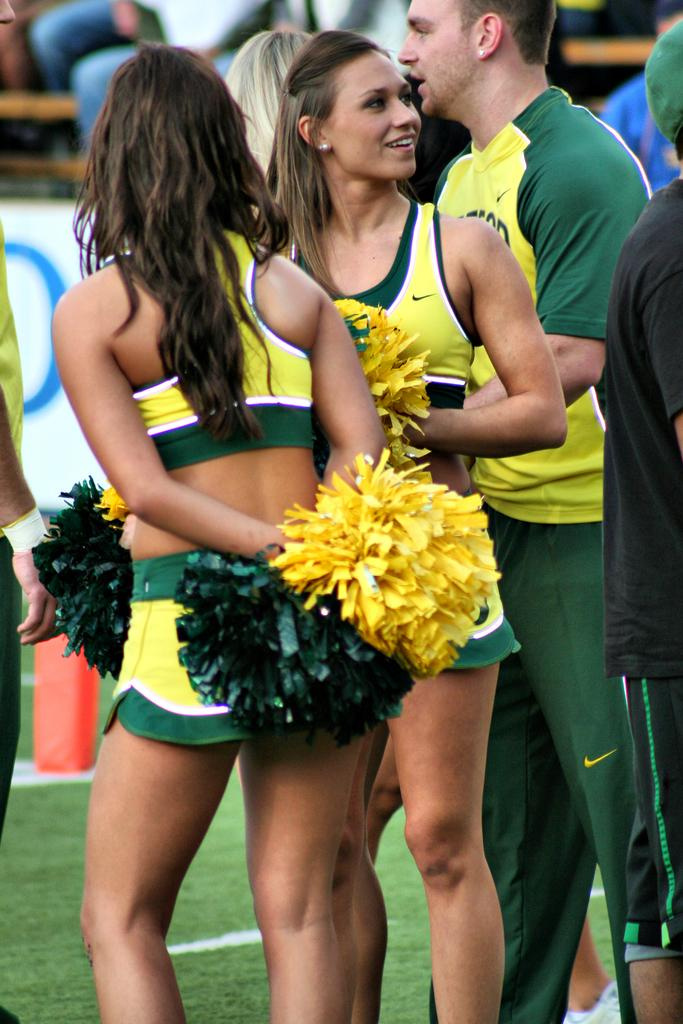What is the general setting of the image? There are people standing on the ground in the image. What are the women holding in their hands? The women are holding color papers in their hands. Are there any ghosts visible in the image? No, there are no ghosts present in the image. What type of cable is being used by the women in the image? There is no cable present in the image; the women are holding color papers. 